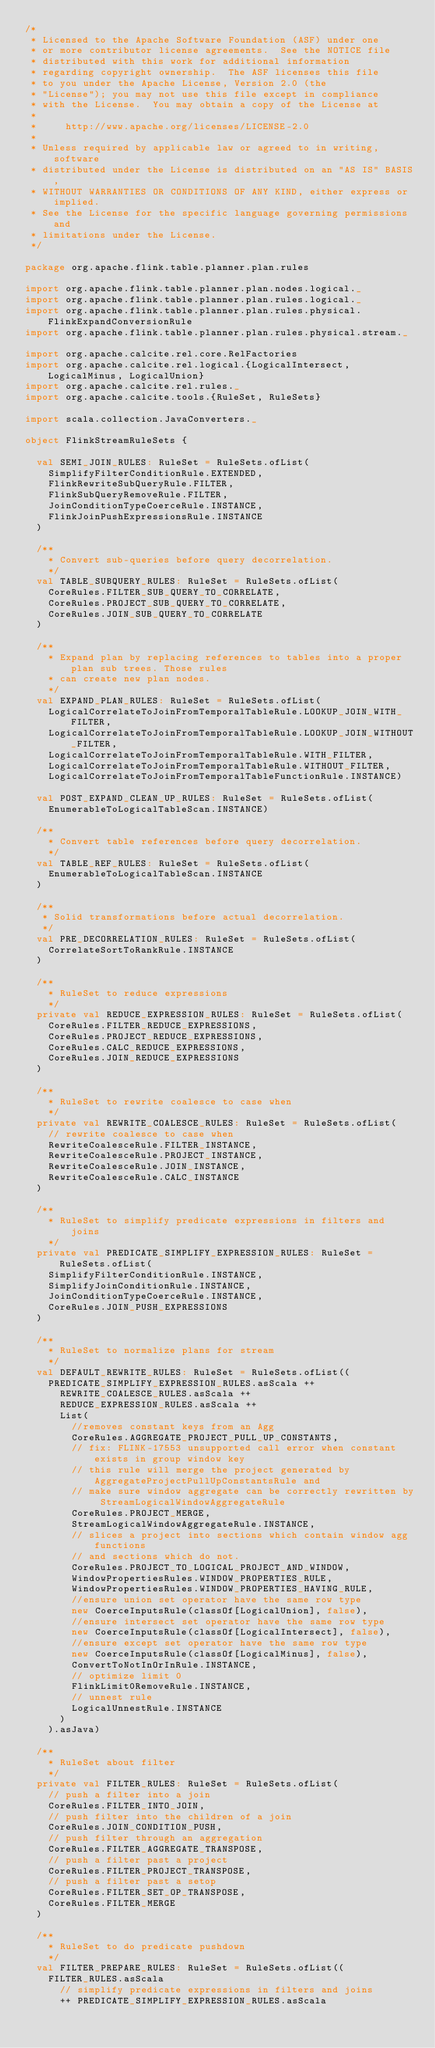Convert code to text. <code><loc_0><loc_0><loc_500><loc_500><_Scala_>/*
 * Licensed to the Apache Software Foundation (ASF) under one
 * or more contributor license agreements.  See the NOTICE file
 * distributed with this work for additional information
 * regarding copyright ownership.  The ASF licenses this file
 * to you under the Apache License, Version 2.0 (the
 * "License"); you may not use this file except in compliance
 * with the License.  You may obtain a copy of the License at
 *
 *     http://www.apache.org/licenses/LICENSE-2.0
 *
 * Unless required by applicable law or agreed to in writing, software
 * distributed under the License is distributed on an "AS IS" BASIS,
 * WITHOUT WARRANTIES OR CONDITIONS OF ANY KIND, either express or implied.
 * See the License for the specific language governing permissions and
 * limitations under the License.
 */

package org.apache.flink.table.planner.plan.rules

import org.apache.flink.table.planner.plan.nodes.logical._
import org.apache.flink.table.planner.plan.rules.logical._
import org.apache.flink.table.planner.plan.rules.physical.FlinkExpandConversionRule
import org.apache.flink.table.planner.plan.rules.physical.stream._

import org.apache.calcite.rel.core.RelFactories
import org.apache.calcite.rel.logical.{LogicalIntersect, LogicalMinus, LogicalUnion}
import org.apache.calcite.rel.rules._
import org.apache.calcite.tools.{RuleSet, RuleSets}

import scala.collection.JavaConverters._

object FlinkStreamRuleSets {

  val SEMI_JOIN_RULES: RuleSet = RuleSets.ofList(
    SimplifyFilterConditionRule.EXTENDED,
    FlinkRewriteSubQueryRule.FILTER,
    FlinkSubQueryRemoveRule.FILTER,
    JoinConditionTypeCoerceRule.INSTANCE,
    FlinkJoinPushExpressionsRule.INSTANCE
  )

  /**
    * Convert sub-queries before query decorrelation.
    */
  val TABLE_SUBQUERY_RULES: RuleSet = RuleSets.ofList(
    CoreRules.FILTER_SUB_QUERY_TO_CORRELATE,
    CoreRules.PROJECT_SUB_QUERY_TO_CORRELATE,
    CoreRules.JOIN_SUB_QUERY_TO_CORRELATE
  )

  /**
    * Expand plan by replacing references to tables into a proper plan sub trees. Those rules
    * can create new plan nodes.
    */
  val EXPAND_PLAN_RULES: RuleSet = RuleSets.ofList(
    LogicalCorrelateToJoinFromTemporalTableRule.LOOKUP_JOIN_WITH_FILTER,
    LogicalCorrelateToJoinFromTemporalTableRule.LOOKUP_JOIN_WITHOUT_FILTER,
    LogicalCorrelateToJoinFromTemporalTableRule.WITH_FILTER,
    LogicalCorrelateToJoinFromTemporalTableRule.WITHOUT_FILTER,
    LogicalCorrelateToJoinFromTemporalTableFunctionRule.INSTANCE)

  val POST_EXPAND_CLEAN_UP_RULES: RuleSet = RuleSets.ofList(
    EnumerableToLogicalTableScan.INSTANCE)

  /**
    * Convert table references before query decorrelation.
    */
  val TABLE_REF_RULES: RuleSet = RuleSets.ofList(
    EnumerableToLogicalTableScan.INSTANCE
  )

  /**
   * Solid transformations before actual decorrelation.
   */
  val PRE_DECORRELATION_RULES: RuleSet = RuleSets.ofList(
    CorrelateSortToRankRule.INSTANCE
  )

  /**
    * RuleSet to reduce expressions
    */
  private val REDUCE_EXPRESSION_RULES: RuleSet = RuleSets.ofList(
    CoreRules.FILTER_REDUCE_EXPRESSIONS,
    CoreRules.PROJECT_REDUCE_EXPRESSIONS,
    CoreRules.CALC_REDUCE_EXPRESSIONS,
    CoreRules.JOIN_REDUCE_EXPRESSIONS
  )

  /**
    * RuleSet to rewrite coalesce to case when
    */
  private val REWRITE_COALESCE_RULES: RuleSet = RuleSets.ofList(
    // rewrite coalesce to case when
    RewriteCoalesceRule.FILTER_INSTANCE,
    RewriteCoalesceRule.PROJECT_INSTANCE,
    RewriteCoalesceRule.JOIN_INSTANCE,
    RewriteCoalesceRule.CALC_INSTANCE
  )

  /**
    * RuleSet to simplify predicate expressions in filters and joins
    */
  private val PREDICATE_SIMPLIFY_EXPRESSION_RULES: RuleSet = RuleSets.ofList(
    SimplifyFilterConditionRule.INSTANCE,
    SimplifyJoinConditionRule.INSTANCE,
    JoinConditionTypeCoerceRule.INSTANCE,
    CoreRules.JOIN_PUSH_EXPRESSIONS
  )

  /**
    * RuleSet to normalize plans for stream
    */
  val DEFAULT_REWRITE_RULES: RuleSet = RuleSets.ofList((
    PREDICATE_SIMPLIFY_EXPRESSION_RULES.asScala ++
      REWRITE_COALESCE_RULES.asScala ++
      REDUCE_EXPRESSION_RULES.asScala ++
      List(
        //removes constant keys from an Agg
        CoreRules.AGGREGATE_PROJECT_PULL_UP_CONSTANTS,
        // fix: FLINK-17553 unsupported call error when constant exists in group window key
        // this rule will merge the project generated by AggregateProjectPullUpConstantsRule and
        // make sure window aggregate can be correctly rewritten by StreamLogicalWindowAggregateRule
        CoreRules.PROJECT_MERGE,
        StreamLogicalWindowAggregateRule.INSTANCE,
        // slices a project into sections which contain window agg functions
        // and sections which do not.
        CoreRules.PROJECT_TO_LOGICAL_PROJECT_AND_WINDOW,
        WindowPropertiesRules.WINDOW_PROPERTIES_RULE,
        WindowPropertiesRules.WINDOW_PROPERTIES_HAVING_RULE,
        //ensure union set operator have the same row type
        new CoerceInputsRule(classOf[LogicalUnion], false),
        //ensure intersect set operator have the same row type
        new CoerceInputsRule(classOf[LogicalIntersect], false),
        //ensure except set operator have the same row type
        new CoerceInputsRule(classOf[LogicalMinus], false),
        ConvertToNotInOrInRule.INSTANCE,
        // optimize limit 0
        FlinkLimit0RemoveRule.INSTANCE,
        // unnest rule
        LogicalUnnestRule.INSTANCE
      )
    ).asJava)

  /**
    * RuleSet about filter
    */
  private val FILTER_RULES: RuleSet = RuleSets.ofList(
    // push a filter into a join
    CoreRules.FILTER_INTO_JOIN,
    // push filter into the children of a join
    CoreRules.JOIN_CONDITION_PUSH,
    // push filter through an aggregation
    CoreRules.FILTER_AGGREGATE_TRANSPOSE,
    // push a filter past a project
    CoreRules.FILTER_PROJECT_TRANSPOSE,
    // push a filter past a setop
    CoreRules.FILTER_SET_OP_TRANSPOSE,
    CoreRules.FILTER_MERGE
  )

  /**
    * RuleSet to do predicate pushdown
    */
  val FILTER_PREPARE_RULES: RuleSet = RuleSets.ofList((
    FILTER_RULES.asScala
      // simplify predicate expressions in filters and joins
      ++ PREDICATE_SIMPLIFY_EXPRESSION_RULES.asScala</code> 